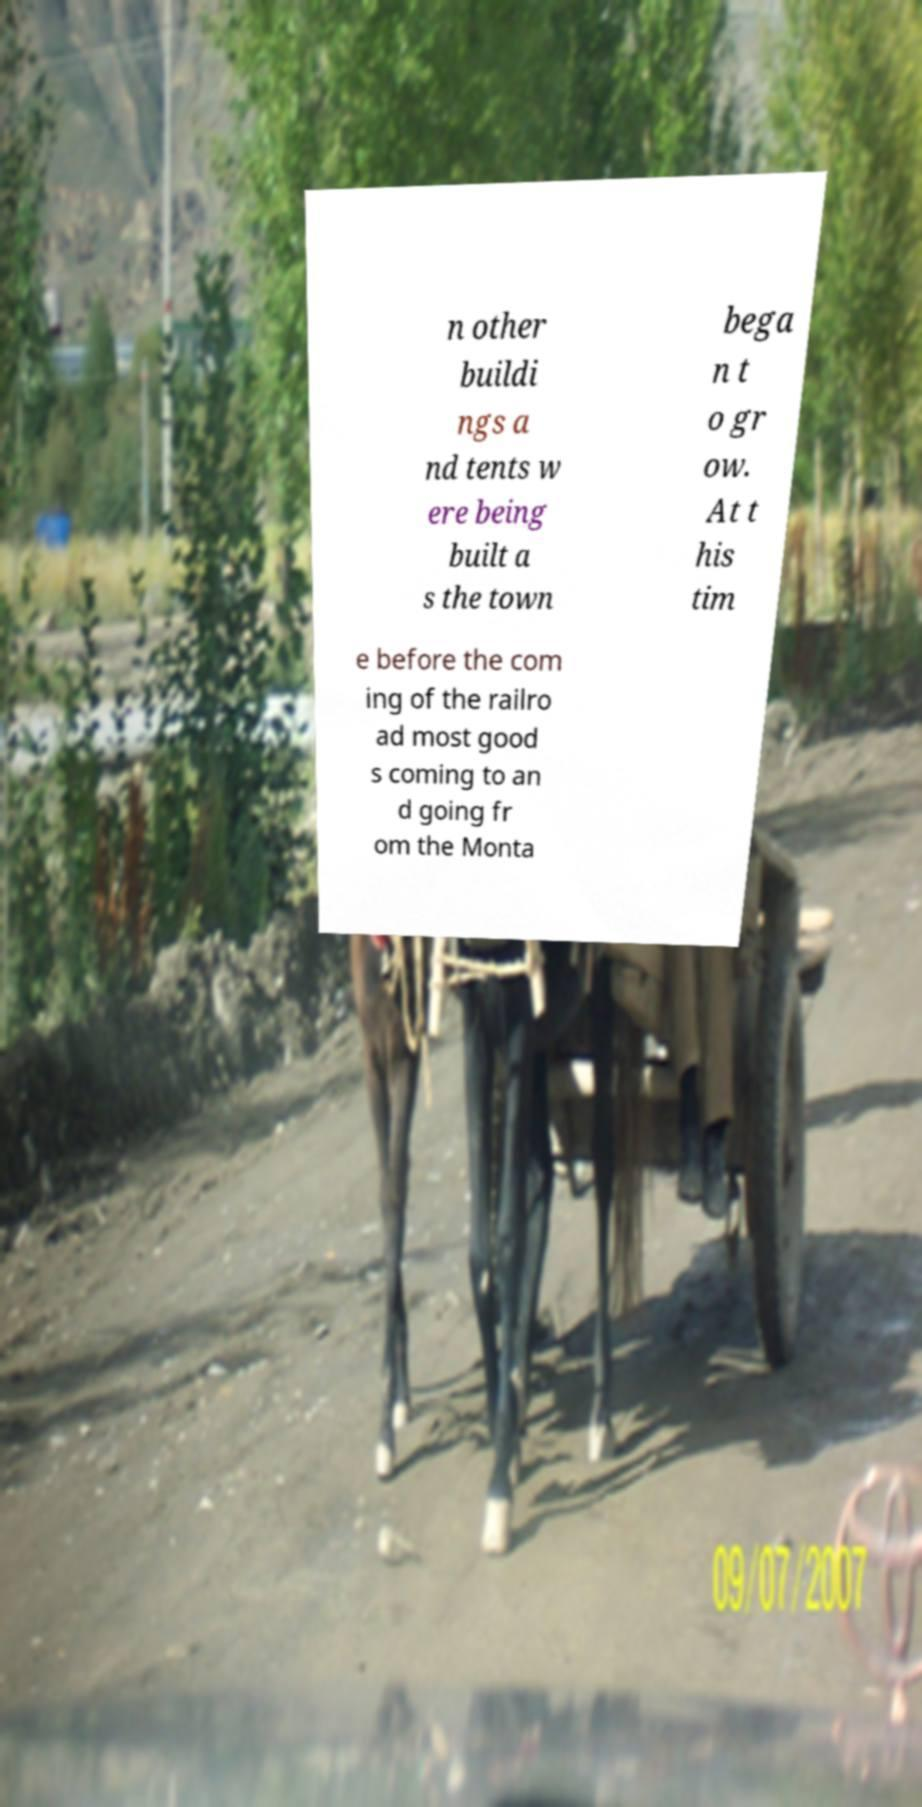I need the written content from this picture converted into text. Can you do that? n other buildi ngs a nd tents w ere being built a s the town bega n t o gr ow. At t his tim e before the com ing of the railro ad most good s coming to an d going fr om the Monta 